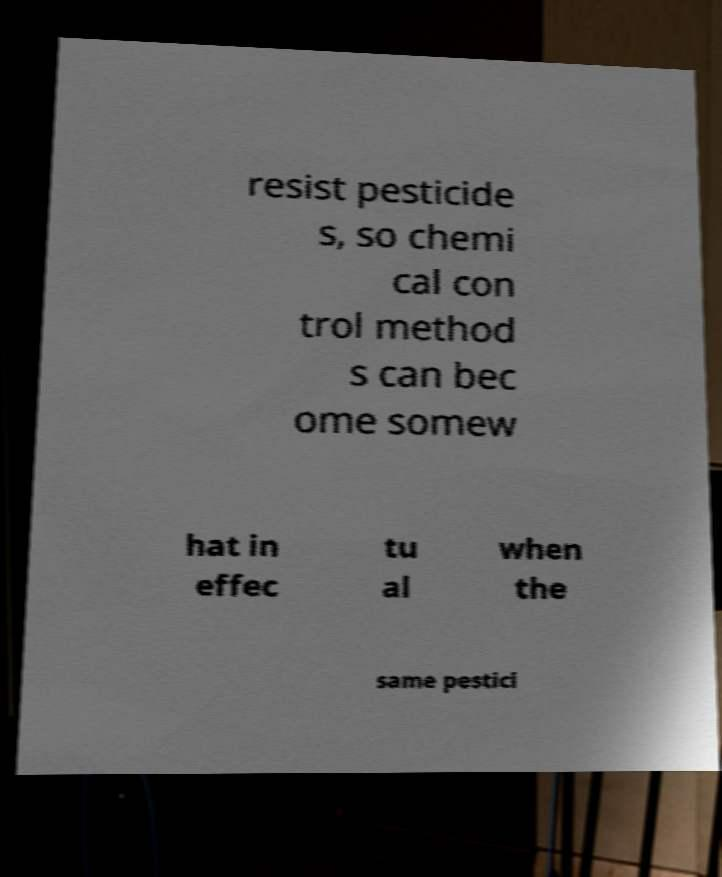What messages or text are displayed in this image? I need them in a readable, typed format. resist pesticide s, so chemi cal con trol method s can bec ome somew hat in effec tu al when the same pestici 